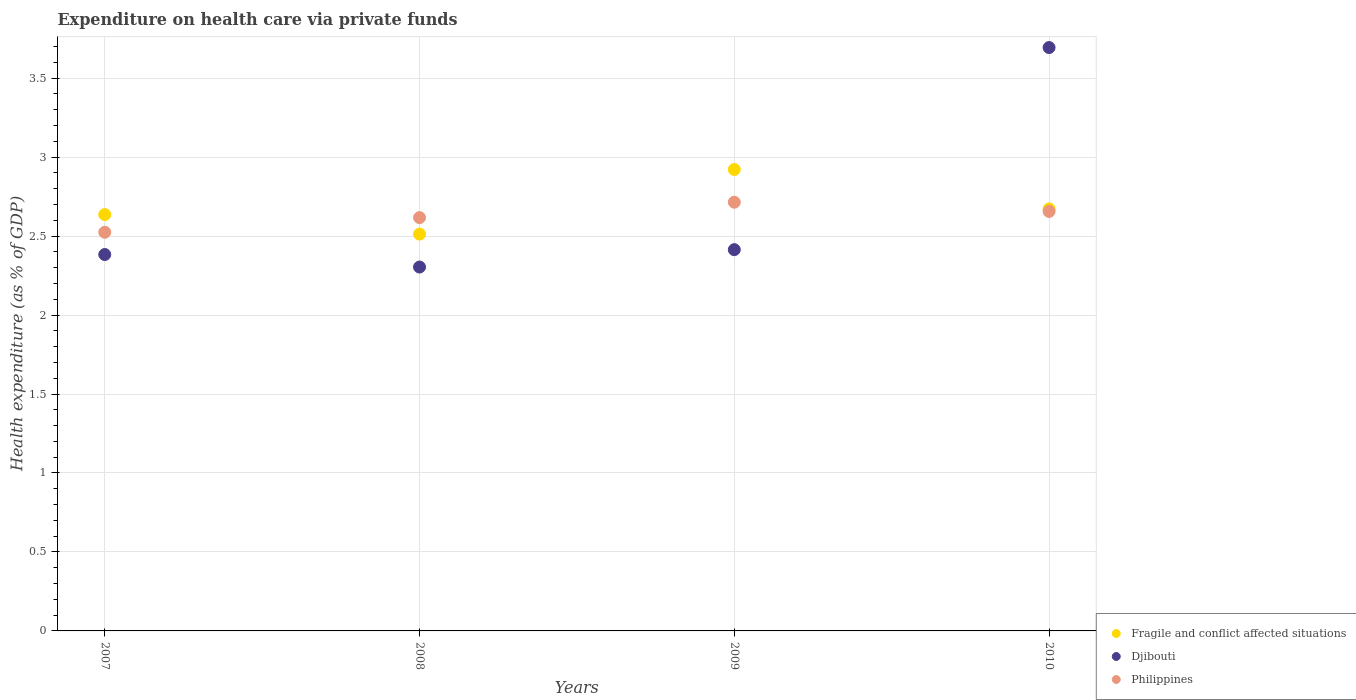Is the number of dotlines equal to the number of legend labels?
Provide a succinct answer. Yes. What is the expenditure made on health care in Philippines in 2009?
Provide a succinct answer. 2.71. Across all years, what is the maximum expenditure made on health care in Djibouti?
Make the answer very short. 3.69. Across all years, what is the minimum expenditure made on health care in Fragile and conflict affected situations?
Provide a short and direct response. 2.51. In which year was the expenditure made on health care in Philippines minimum?
Ensure brevity in your answer.  2007. What is the total expenditure made on health care in Fragile and conflict affected situations in the graph?
Keep it short and to the point. 10.74. What is the difference between the expenditure made on health care in Fragile and conflict affected situations in 2007 and that in 2008?
Your answer should be compact. 0.12. What is the difference between the expenditure made on health care in Fragile and conflict affected situations in 2007 and the expenditure made on health care in Philippines in 2008?
Give a very brief answer. 0.02. What is the average expenditure made on health care in Djibouti per year?
Make the answer very short. 2.7. In the year 2010, what is the difference between the expenditure made on health care in Fragile and conflict affected situations and expenditure made on health care in Philippines?
Offer a very short reply. 0.02. In how many years, is the expenditure made on health care in Fragile and conflict affected situations greater than 3 %?
Offer a terse response. 0. What is the ratio of the expenditure made on health care in Philippines in 2007 to that in 2008?
Give a very brief answer. 0.96. What is the difference between the highest and the second highest expenditure made on health care in Fragile and conflict affected situations?
Offer a very short reply. 0.25. What is the difference between the highest and the lowest expenditure made on health care in Djibouti?
Give a very brief answer. 1.39. In how many years, is the expenditure made on health care in Philippines greater than the average expenditure made on health care in Philippines taken over all years?
Offer a terse response. 2. Is it the case that in every year, the sum of the expenditure made on health care in Fragile and conflict affected situations and expenditure made on health care in Philippines  is greater than the expenditure made on health care in Djibouti?
Your response must be concise. Yes. Is the expenditure made on health care in Fragile and conflict affected situations strictly greater than the expenditure made on health care in Philippines over the years?
Keep it short and to the point. No. How many dotlines are there?
Make the answer very short. 3. Does the graph contain any zero values?
Your answer should be very brief. No. How many legend labels are there?
Make the answer very short. 3. What is the title of the graph?
Give a very brief answer. Expenditure on health care via private funds. Does "New Zealand" appear as one of the legend labels in the graph?
Your response must be concise. No. What is the label or title of the Y-axis?
Your answer should be very brief. Health expenditure (as % of GDP). What is the Health expenditure (as % of GDP) of Fragile and conflict affected situations in 2007?
Your response must be concise. 2.64. What is the Health expenditure (as % of GDP) of Djibouti in 2007?
Provide a short and direct response. 2.38. What is the Health expenditure (as % of GDP) in Philippines in 2007?
Offer a terse response. 2.52. What is the Health expenditure (as % of GDP) of Fragile and conflict affected situations in 2008?
Offer a very short reply. 2.51. What is the Health expenditure (as % of GDP) in Djibouti in 2008?
Keep it short and to the point. 2.3. What is the Health expenditure (as % of GDP) of Philippines in 2008?
Your answer should be compact. 2.62. What is the Health expenditure (as % of GDP) of Fragile and conflict affected situations in 2009?
Provide a short and direct response. 2.92. What is the Health expenditure (as % of GDP) in Djibouti in 2009?
Your answer should be very brief. 2.41. What is the Health expenditure (as % of GDP) of Philippines in 2009?
Provide a succinct answer. 2.71. What is the Health expenditure (as % of GDP) in Fragile and conflict affected situations in 2010?
Offer a very short reply. 2.67. What is the Health expenditure (as % of GDP) in Djibouti in 2010?
Your answer should be compact. 3.69. What is the Health expenditure (as % of GDP) in Philippines in 2010?
Your answer should be compact. 2.66. Across all years, what is the maximum Health expenditure (as % of GDP) in Fragile and conflict affected situations?
Keep it short and to the point. 2.92. Across all years, what is the maximum Health expenditure (as % of GDP) of Djibouti?
Offer a very short reply. 3.69. Across all years, what is the maximum Health expenditure (as % of GDP) in Philippines?
Give a very brief answer. 2.71. Across all years, what is the minimum Health expenditure (as % of GDP) of Fragile and conflict affected situations?
Make the answer very short. 2.51. Across all years, what is the minimum Health expenditure (as % of GDP) of Djibouti?
Keep it short and to the point. 2.3. Across all years, what is the minimum Health expenditure (as % of GDP) of Philippines?
Offer a very short reply. 2.52. What is the total Health expenditure (as % of GDP) of Fragile and conflict affected situations in the graph?
Your answer should be very brief. 10.74. What is the total Health expenditure (as % of GDP) of Djibouti in the graph?
Ensure brevity in your answer.  10.79. What is the total Health expenditure (as % of GDP) in Philippines in the graph?
Give a very brief answer. 10.51. What is the difference between the Health expenditure (as % of GDP) in Fragile and conflict affected situations in 2007 and that in 2008?
Make the answer very short. 0.12. What is the difference between the Health expenditure (as % of GDP) in Djibouti in 2007 and that in 2008?
Make the answer very short. 0.08. What is the difference between the Health expenditure (as % of GDP) in Philippines in 2007 and that in 2008?
Make the answer very short. -0.09. What is the difference between the Health expenditure (as % of GDP) of Fragile and conflict affected situations in 2007 and that in 2009?
Offer a very short reply. -0.29. What is the difference between the Health expenditure (as % of GDP) of Djibouti in 2007 and that in 2009?
Your answer should be compact. -0.03. What is the difference between the Health expenditure (as % of GDP) of Philippines in 2007 and that in 2009?
Keep it short and to the point. -0.19. What is the difference between the Health expenditure (as % of GDP) of Fragile and conflict affected situations in 2007 and that in 2010?
Provide a short and direct response. -0.04. What is the difference between the Health expenditure (as % of GDP) in Djibouti in 2007 and that in 2010?
Provide a succinct answer. -1.31. What is the difference between the Health expenditure (as % of GDP) in Philippines in 2007 and that in 2010?
Offer a very short reply. -0.13. What is the difference between the Health expenditure (as % of GDP) in Fragile and conflict affected situations in 2008 and that in 2009?
Your answer should be very brief. -0.41. What is the difference between the Health expenditure (as % of GDP) in Djibouti in 2008 and that in 2009?
Keep it short and to the point. -0.11. What is the difference between the Health expenditure (as % of GDP) in Philippines in 2008 and that in 2009?
Provide a short and direct response. -0.1. What is the difference between the Health expenditure (as % of GDP) of Fragile and conflict affected situations in 2008 and that in 2010?
Give a very brief answer. -0.16. What is the difference between the Health expenditure (as % of GDP) in Djibouti in 2008 and that in 2010?
Keep it short and to the point. -1.39. What is the difference between the Health expenditure (as % of GDP) in Philippines in 2008 and that in 2010?
Make the answer very short. -0.04. What is the difference between the Health expenditure (as % of GDP) of Fragile and conflict affected situations in 2009 and that in 2010?
Ensure brevity in your answer.  0.25. What is the difference between the Health expenditure (as % of GDP) of Djibouti in 2009 and that in 2010?
Your answer should be compact. -1.28. What is the difference between the Health expenditure (as % of GDP) of Philippines in 2009 and that in 2010?
Your response must be concise. 0.06. What is the difference between the Health expenditure (as % of GDP) of Fragile and conflict affected situations in 2007 and the Health expenditure (as % of GDP) of Djibouti in 2008?
Give a very brief answer. 0.33. What is the difference between the Health expenditure (as % of GDP) of Fragile and conflict affected situations in 2007 and the Health expenditure (as % of GDP) of Philippines in 2008?
Make the answer very short. 0.02. What is the difference between the Health expenditure (as % of GDP) of Djibouti in 2007 and the Health expenditure (as % of GDP) of Philippines in 2008?
Provide a succinct answer. -0.23. What is the difference between the Health expenditure (as % of GDP) of Fragile and conflict affected situations in 2007 and the Health expenditure (as % of GDP) of Djibouti in 2009?
Offer a very short reply. 0.22. What is the difference between the Health expenditure (as % of GDP) in Fragile and conflict affected situations in 2007 and the Health expenditure (as % of GDP) in Philippines in 2009?
Make the answer very short. -0.08. What is the difference between the Health expenditure (as % of GDP) in Djibouti in 2007 and the Health expenditure (as % of GDP) in Philippines in 2009?
Offer a very short reply. -0.33. What is the difference between the Health expenditure (as % of GDP) in Fragile and conflict affected situations in 2007 and the Health expenditure (as % of GDP) in Djibouti in 2010?
Provide a succinct answer. -1.06. What is the difference between the Health expenditure (as % of GDP) in Fragile and conflict affected situations in 2007 and the Health expenditure (as % of GDP) in Philippines in 2010?
Give a very brief answer. -0.02. What is the difference between the Health expenditure (as % of GDP) of Djibouti in 2007 and the Health expenditure (as % of GDP) of Philippines in 2010?
Keep it short and to the point. -0.27. What is the difference between the Health expenditure (as % of GDP) of Fragile and conflict affected situations in 2008 and the Health expenditure (as % of GDP) of Djibouti in 2009?
Your response must be concise. 0.1. What is the difference between the Health expenditure (as % of GDP) in Fragile and conflict affected situations in 2008 and the Health expenditure (as % of GDP) in Philippines in 2009?
Make the answer very short. -0.2. What is the difference between the Health expenditure (as % of GDP) of Djibouti in 2008 and the Health expenditure (as % of GDP) of Philippines in 2009?
Ensure brevity in your answer.  -0.41. What is the difference between the Health expenditure (as % of GDP) in Fragile and conflict affected situations in 2008 and the Health expenditure (as % of GDP) in Djibouti in 2010?
Your answer should be compact. -1.18. What is the difference between the Health expenditure (as % of GDP) in Fragile and conflict affected situations in 2008 and the Health expenditure (as % of GDP) in Philippines in 2010?
Provide a succinct answer. -0.14. What is the difference between the Health expenditure (as % of GDP) in Djibouti in 2008 and the Health expenditure (as % of GDP) in Philippines in 2010?
Give a very brief answer. -0.35. What is the difference between the Health expenditure (as % of GDP) of Fragile and conflict affected situations in 2009 and the Health expenditure (as % of GDP) of Djibouti in 2010?
Provide a short and direct response. -0.77. What is the difference between the Health expenditure (as % of GDP) of Fragile and conflict affected situations in 2009 and the Health expenditure (as % of GDP) of Philippines in 2010?
Your answer should be very brief. 0.27. What is the difference between the Health expenditure (as % of GDP) of Djibouti in 2009 and the Health expenditure (as % of GDP) of Philippines in 2010?
Your answer should be compact. -0.24. What is the average Health expenditure (as % of GDP) of Fragile and conflict affected situations per year?
Your answer should be very brief. 2.69. What is the average Health expenditure (as % of GDP) of Djibouti per year?
Give a very brief answer. 2.7. What is the average Health expenditure (as % of GDP) in Philippines per year?
Offer a terse response. 2.63. In the year 2007, what is the difference between the Health expenditure (as % of GDP) in Fragile and conflict affected situations and Health expenditure (as % of GDP) in Djibouti?
Provide a short and direct response. 0.25. In the year 2007, what is the difference between the Health expenditure (as % of GDP) of Fragile and conflict affected situations and Health expenditure (as % of GDP) of Philippines?
Your answer should be very brief. 0.11. In the year 2007, what is the difference between the Health expenditure (as % of GDP) of Djibouti and Health expenditure (as % of GDP) of Philippines?
Your answer should be compact. -0.14. In the year 2008, what is the difference between the Health expenditure (as % of GDP) of Fragile and conflict affected situations and Health expenditure (as % of GDP) of Djibouti?
Offer a very short reply. 0.21. In the year 2008, what is the difference between the Health expenditure (as % of GDP) in Fragile and conflict affected situations and Health expenditure (as % of GDP) in Philippines?
Make the answer very short. -0.1. In the year 2008, what is the difference between the Health expenditure (as % of GDP) in Djibouti and Health expenditure (as % of GDP) in Philippines?
Give a very brief answer. -0.31. In the year 2009, what is the difference between the Health expenditure (as % of GDP) in Fragile and conflict affected situations and Health expenditure (as % of GDP) in Djibouti?
Offer a terse response. 0.51. In the year 2009, what is the difference between the Health expenditure (as % of GDP) in Fragile and conflict affected situations and Health expenditure (as % of GDP) in Philippines?
Make the answer very short. 0.21. In the year 2009, what is the difference between the Health expenditure (as % of GDP) in Djibouti and Health expenditure (as % of GDP) in Philippines?
Offer a terse response. -0.3. In the year 2010, what is the difference between the Health expenditure (as % of GDP) of Fragile and conflict affected situations and Health expenditure (as % of GDP) of Djibouti?
Ensure brevity in your answer.  -1.02. In the year 2010, what is the difference between the Health expenditure (as % of GDP) of Fragile and conflict affected situations and Health expenditure (as % of GDP) of Philippines?
Your answer should be very brief. 0.02. In the year 2010, what is the difference between the Health expenditure (as % of GDP) in Djibouti and Health expenditure (as % of GDP) in Philippines?
Your answer should be very brief. 1.04. What is the ratio of the Health expenditure (as % of GDP) of Fragile and conflict affected situations in 2007 to that in 2008?
Give a very brief answer. 1.05. What is the ratio of the Health expenditure (as % of GDP) of Djibouti in 2007 to that in 2008?
Offer a terse response. 1.03. What is the ratio of the Health expenditure (as % of GDP) in Philippines in 2007 to that in 2008?
Offer a terse response. 0.96. What is the ratio of the Health expenditure (as % of GDP) in Fragile and conflict affected situations in 2007 to that in 2009?
Provide a succinct answer. 0.9. What is the ratio of the Health expenditure (as % of GDP) of Djibouti in 2007 to that in 2009?
Give a very brief answer. 0.99. What is the ratio of the Health expenditure (as % of GDP) of Philippines in 2007 to that in 2009?
Offer a terse response. 0.93. What is the ratio of the Health expenditure (as % of GDP) in Fragile and conflict affected situations in 2007 to that in 2010?
Give a very brief answer. 0.99. What is the ratio of the Health expenditure (as % of GDP) of Djibouti in 2007 to that in 2010?
Keep it short and to the point. 0.65. What is the ratio of the Health expenditure (as % of GDP) of Philippines in 2007 to that in 2010?
Your answer should be compact. 0.95. What is the ratio of the Health expenditure (as % of GDP) in Fragile and conflict affected situations in 2008 to that in 2009?
Your response must be concise. 0.86. What is the ratio of the Health expenditure (as % of GDP) in Djibouti in 2008 to that in 2009?
Your answer should be very brief. 0.95. What is the ratio of the Health expenditure (as % of GDP) of Philippines in 2008 to that in 2009?
Offer a very short reply. 0.96. What is the ratio of the Health expenditure (as % of GDP) in Fragile and conflict affected situations in 2008 to that in 2010?
Offer a terse response. 0.94. What is the ratio of the Health expenditure (as % of GDP) in Djibouti in 2008 to that in 2010?
Offer a very short reply. 0.62. What is the ratio of the Health expenditure (as % of GDP) of Philippines in 2008 to that in 2010?
Provide a short and direct response. 0.99. What is the ratio of the Health expenditure (as % of GDP) in Fragile and conflict affected situations in 2009 to that in 2010?
Provide a short and direct response. 1.09. What is the ratio of the Health expenditure (as % of GDP) of Djibouti in 2009 to that in 2010?
Make the answer very short. 0.65. What is the difference between the highest and the second highest Health expenditure (as % of GDP) in Fragile and conflict affected situations?
Provide a short and direct response. 0.25. What is the difference between the highest and the second highest Health expenditure (as % of GDP) in Djibouti?
Keep it short and to the point. 1.28. What is the difference between the highest and the second highest Health expenditure (as % of GDP) in Philippines?
Ensure brevity in your answer.  0.06. What is the difference between the highest and the lowest Health expenditure (as % of GDP) in Fragile and conflict affected situations?
Offer a very short reply. 0.41. What is the difference between the highest and the lowest Health expenditure (as % of GDP) of Djibouti?
Offer a very short reply. 1.39. What is the difference between the highest and the lowest Health expenditure (as % of GDP) in Philippines?
Offer a very short reply. 0.19. 